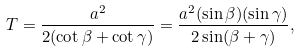<formula> <loc_0><loc_0><loc_500><loc_500>T = { \frac { a ^ { 2 } } { 2 ( \cot \beta + \cot \gamma ) } } = { \frac { a ^ { 2 } ( \sin \beta ) ( \sin \gamma ) } { 2 \sin ( \beta + \gamma ) } } ,</formula> 